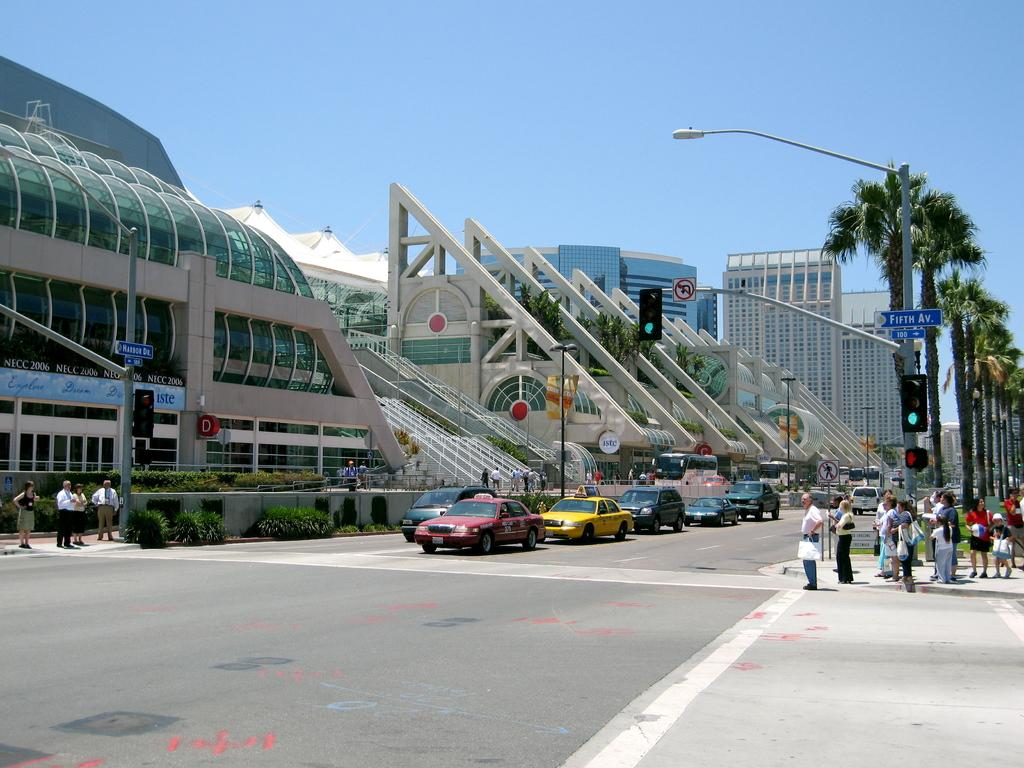What can be seen on the roadside in the image? There are vehicles on the roadside in the image. What are the people near the vehicles doing? There are people standing near the vehicles. What type of structures can be seen in the image? There are buildings visible in the image. What type of vegetation is present in the image? There are trees present in the image. Where is the playground located in the image? There is no playground present in the image. What type of produce is being sold near the vehicles? There is no produce being sold in the image; the focus is on the vehicles and people standing near them. 